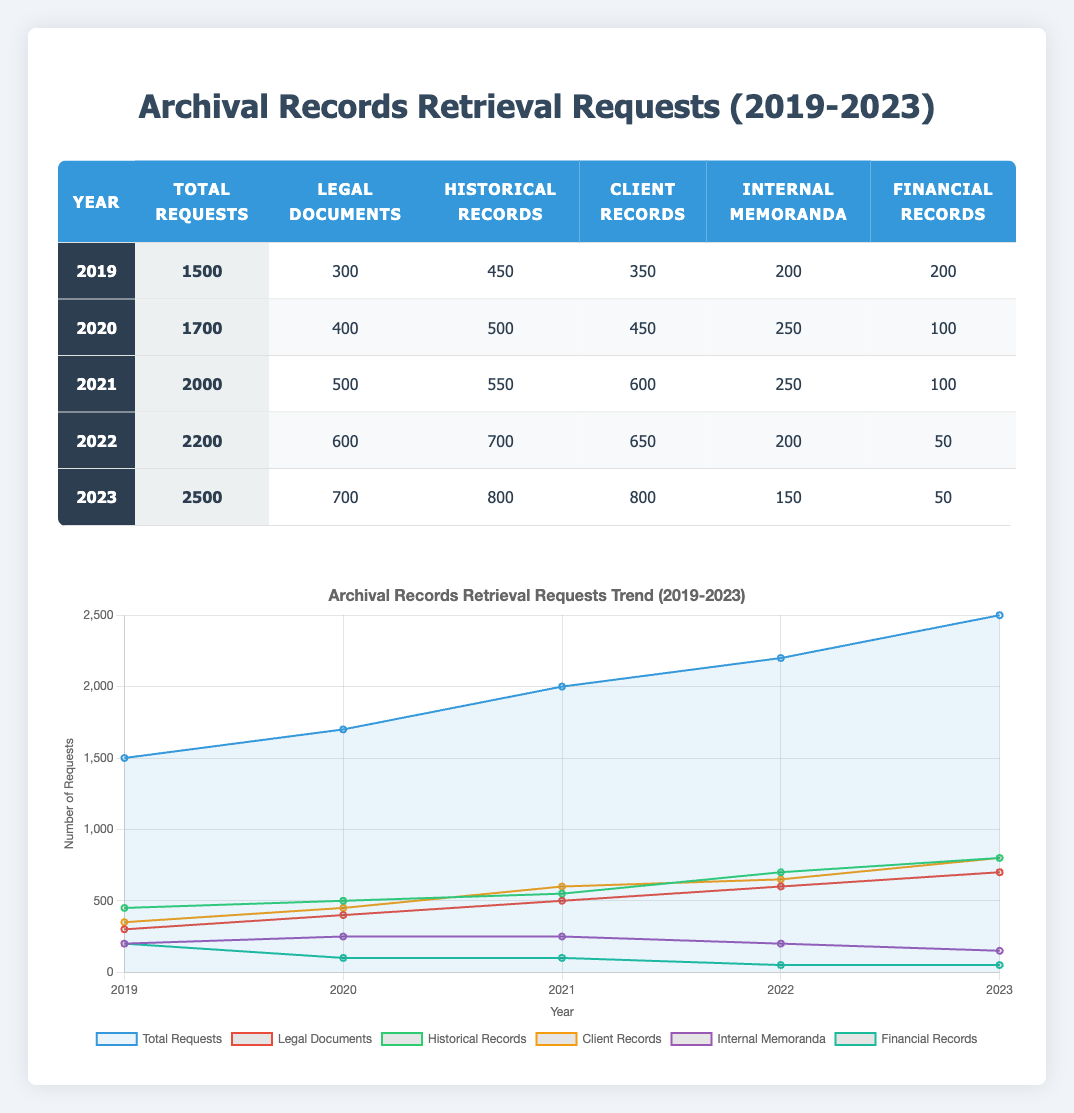What was the total number of retrieval requests in 2021? Looking at the row for the year 2021 in the table, the total number of requests is specified as 2000.
Answer: 2000 Which type of archival record had the highest number of requests in 2022? In 2022, I compare the number of requests for each type of archival record. The numbers are: Legal Documents (600), Historical Records (700), Client Records (650), Internal Memoranda (200), and Financial Records (50). The highest is Historical Records with 700 requests.
Answer: Historical Records What was the increase in total requests from 2019 to 2023? The total requests in 2019 were 1500, and in 2023 they rose to 2500. The increase is calculated as 2500 - 1500 = 1000.
Answer: 1000 Did the number of retrieval requests for internal memoranda decrease over the years? Looking at the internal memoranda requests for each year: 2019 had 200, 2020 had 250, 2021 had 250, 2022 had 200, and 2023 had 150. The trend shows a decrease from 2020 to 2023, confirming the statement.
Answer: Yes What is the average number of financial record requests over the reported years? I total the financial record requests: 200 (2019) + 100 (2020) + 100 (2021) + 50 (2022) + 50 (2023) = 600. There are 5 years, so the average is 600 / 5 = 120.
Answer: 120 Which year had the most retrieval requests for legal documents? By looking at the legal document requests for each year, 2019 had 300, 2020 had 400, 2021 had 500, 2022 had 600, and 2023 had 700. The highest was in 2023 with 700 requests.
Answer: 2023 What was the percentage of client records requests out of the total requests in 2021? In 2021, the total requests were 2000, and the client records requests were 600. The percentage is calculated as (600 / 2000) * 100 = 30%.
Answer: 30% How many more historical records requests were there compared to financial records requests in 2020? In 2020, the historical records requests were 500 and financial records were 100. The difference is calculated as 500 - 100 = 400.
Answer: 400 How did the number of total requests change from 2020 to 2022? From the data, total requests in 2020 were 1700 and in 2022 they were 2200. The change is 2200 - 1700 = 500, indicating an increase.
Answer: Increased by 500 